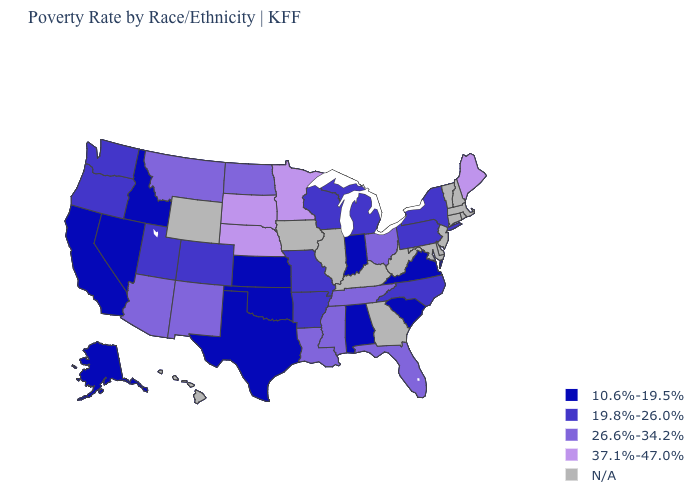Among the states that border Minnesota , which have the highest value?
Give a very brief answer. South Dakota. Which states have the lowest value in the MidWest?
Keep it brief. Indiana, Kansas. What is the value of Arkansas?
Write a very short answer. 19.8%-26.0%. What is the value of South Carolina?
Keep it brief. 10.6%-19.5%. Does Montana have the highest value in the USA?
Answer briefly. No. What is the value of Texas?
Answer briefly. 10.6%-19.5%. Name the states that have a value in the range 37.1%-47.0%?
Answer briefly. Maine, Minnesota, Nebraska, South Dakota. Does Indiana have the lowest value in the USA?
Write a very short answer. Yes. What is the highest value in the MidWest ?
Keep it brief. 37.1%-47.0%. What is the value of Louisiana?
Quick response, please. 26.6%-34.2%. Name the states that have a value in the range 26.6%-34.2%?
Short answer required. Arizona, Florida, Louisiana, Mississippi, Montana, New Mexico, North Dakota, Ohio, Tennessee. What is the value of Montana?
Quick response, please. 26.6%-34.2%. Which states hav the highest value in the MidWest?
Answer briefly. Minnesota, Nebraska, South Dakota. What is the highest value in states that border Pennsylvania?
Be succinct. 26.6%-34.2%. 